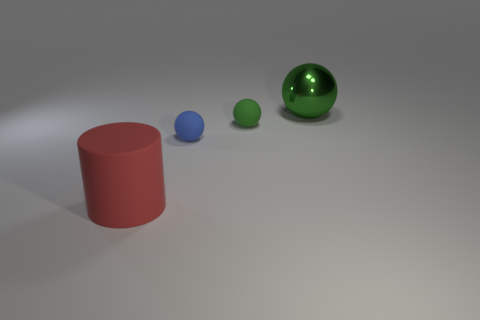Add 1 cylinders. How many objects exist? 5 Subtract all spheres. How many objects are left? 1 Add 3 big brown matte objects. How many big brown matte objects exist? 3 Subtract 1 green balls. How many objects are left? 3 Subtract all big things. Subtract all green rubber blocks. How many objects are left? 2 Add 4 blue things. How many blue things are left? 5 